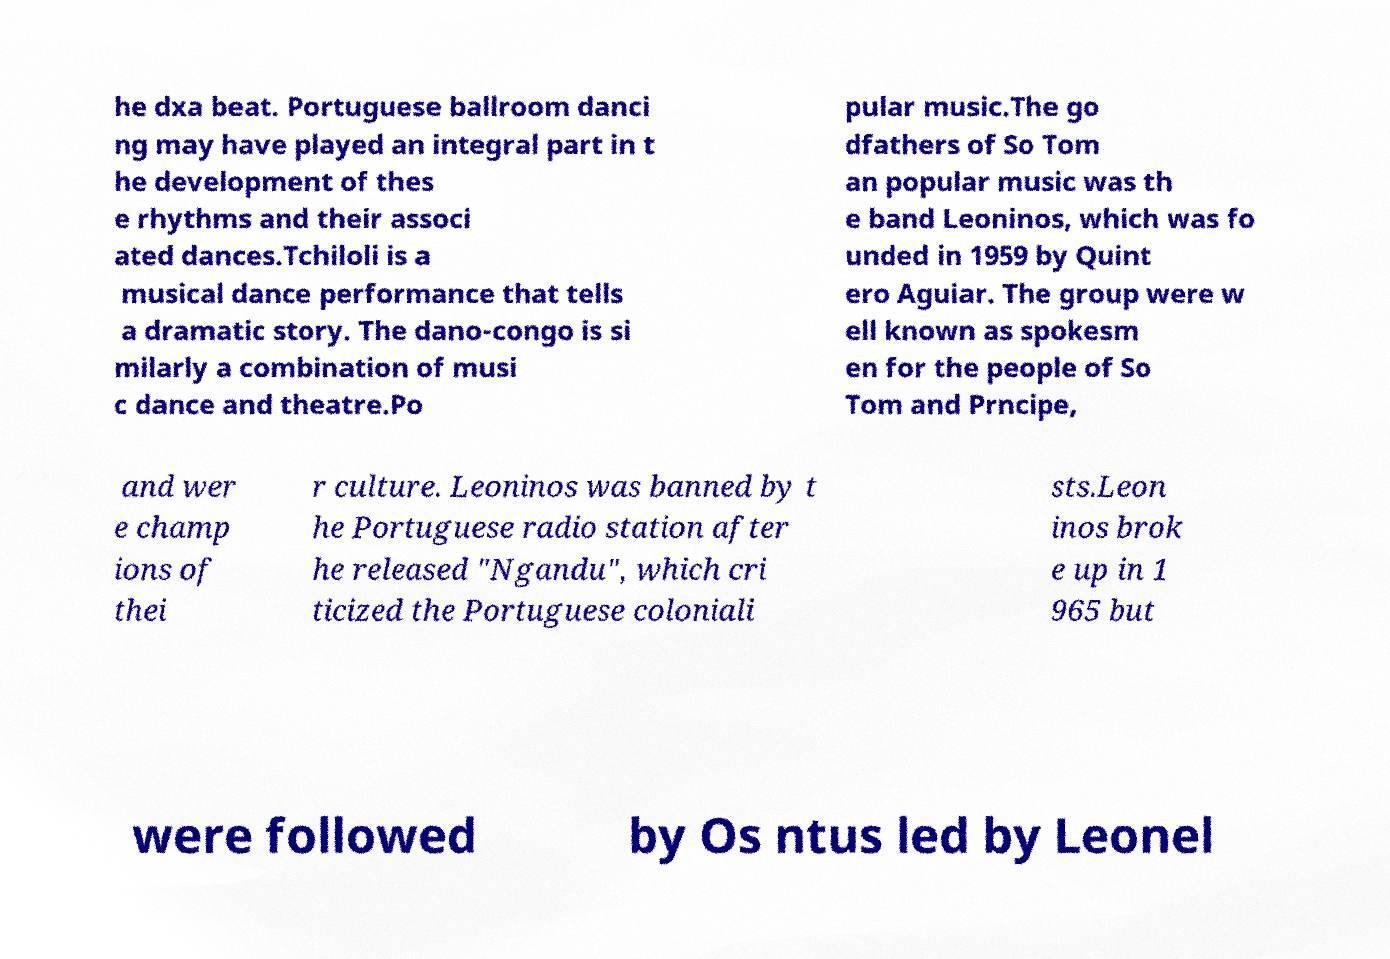For documentation purposes, I need the text within this image transcribed. Could you provide that? he dxa beat. Portuguese ballroom danci ng may have played an integral part in t he development of thes e rhythms and their associ ated dances.Tchiloli is a musical dance performance that tells a dramatic story. The dano-congo is si milarly a combination of musi c dance and theatre.Po pular music.The go dfathers of So Tom an popular music was th e band Leoninos, which was fo unded in 1959 by Quint ero Aguiar. The group were w ell known as spokesm en for the people of So Tom and Prncipe, and wer e champ ions of thei r culture. Leoninos was banned by t he Portuguese radio station after he released "Ngandu", which cri ticized the Portuguese coloniali sts.Leon inos brok e up in 1 965 but were followed by Os ntus led by Leonel 